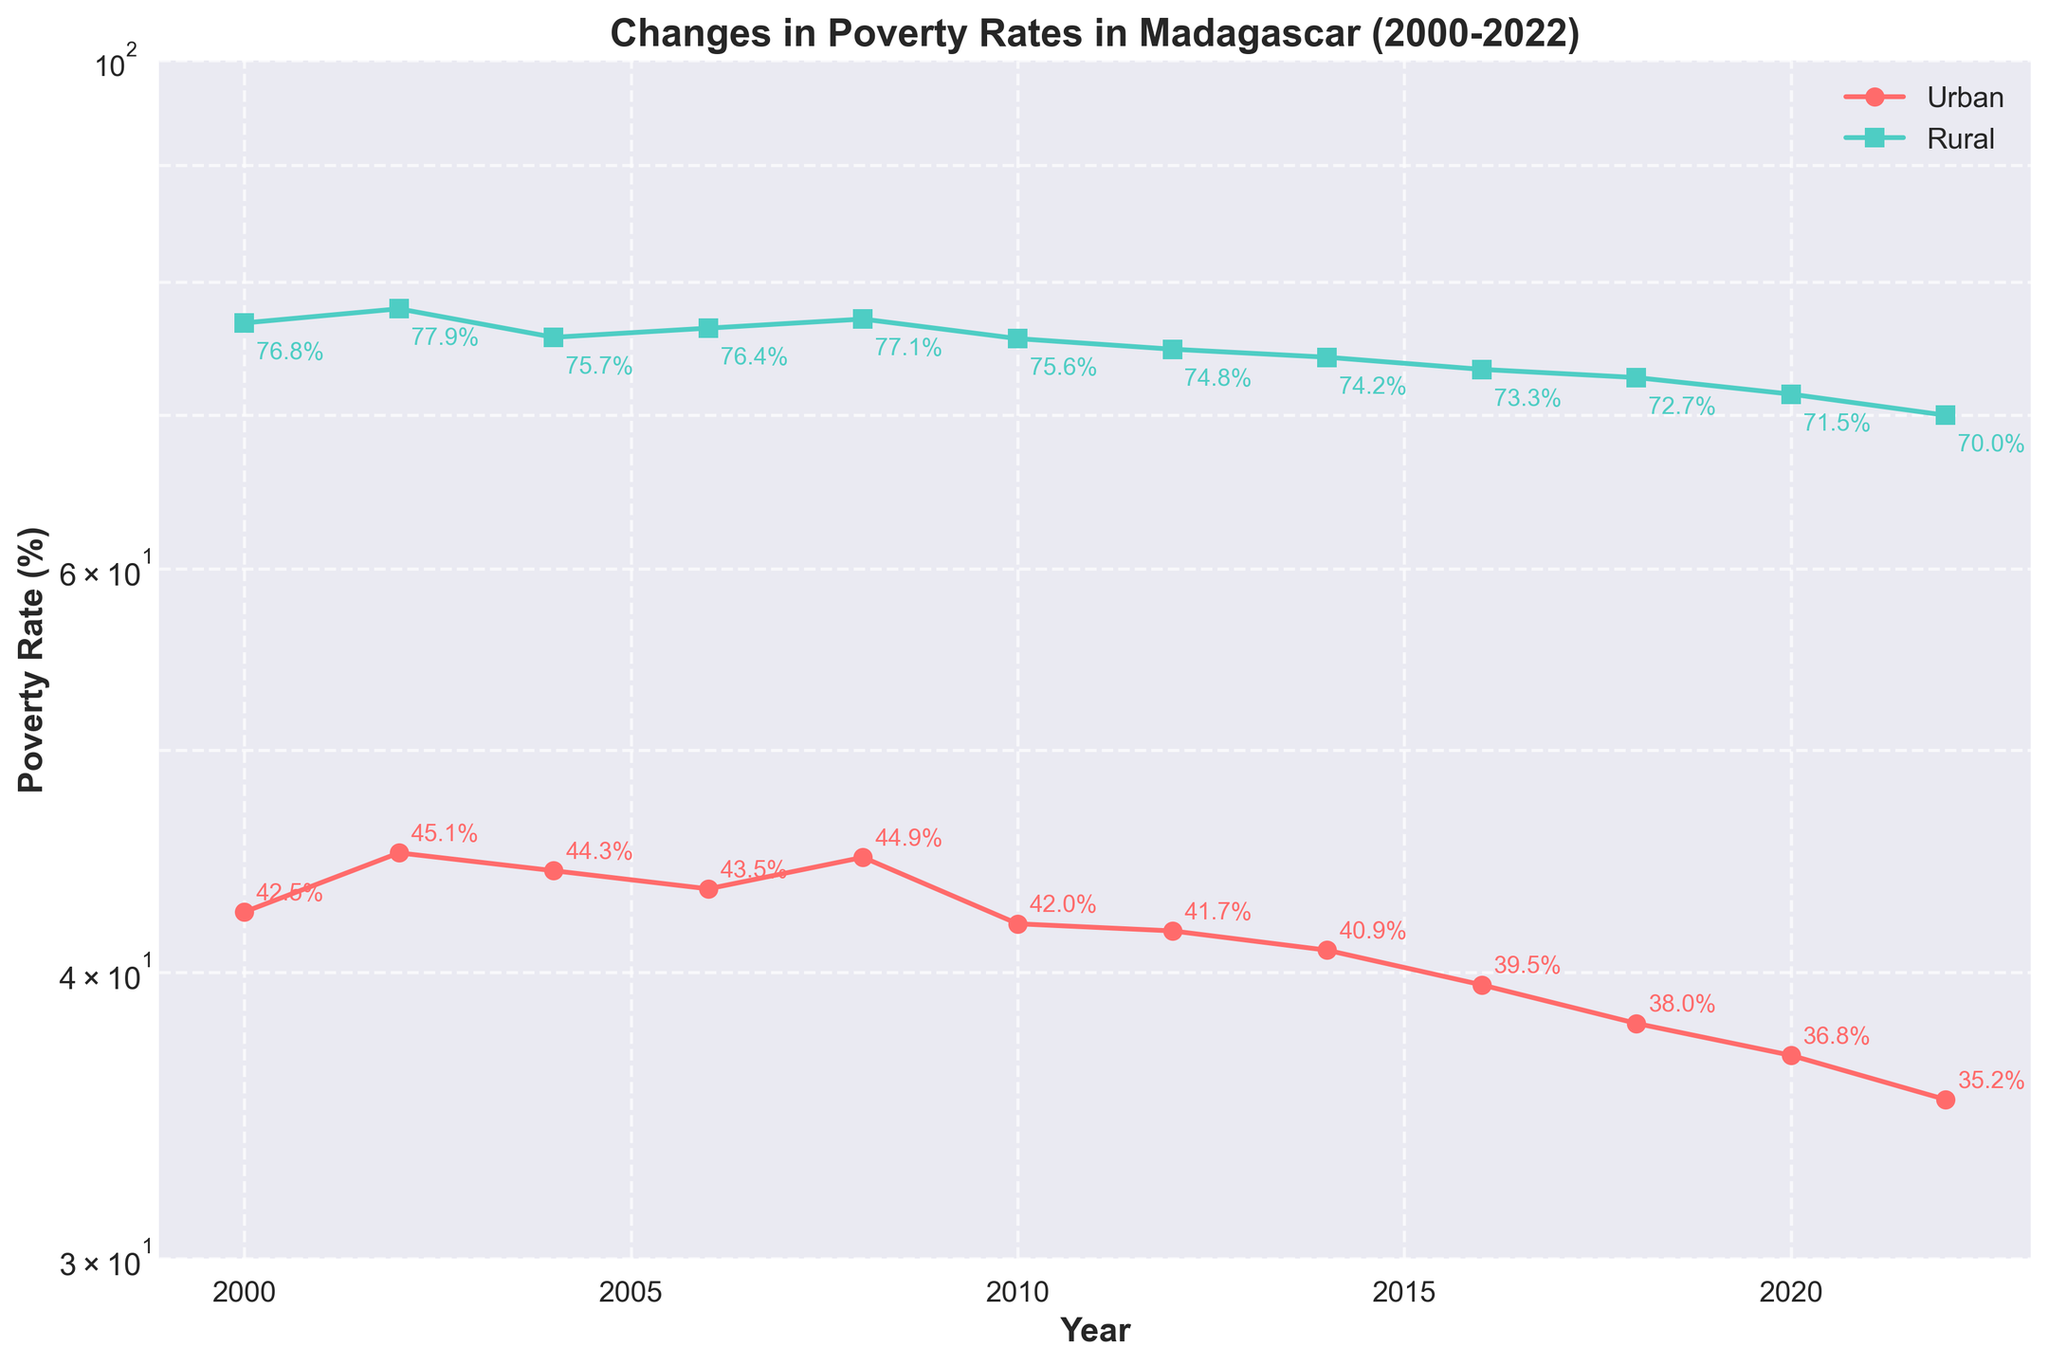What is the title of the plot? The title of the plot is displayed at the top of the figure in bold font, providing an overall summary of what the figure is representing.
Answer: Changes in Poverty Rates in Madagascar (2000-2022) What is the urban poverty rate in 2022? Find the value corresponding to the "Urban" line for the year 2022 and note the percentage.
Answer: 35.2% Which year had the highest rural poverty rate? Look across the "Rural" line and find the highest value, then refer back to the corresponding year.
Answer: 2002 How much did the urban poverty rate change between 2008 and 2018? Locate the values for the urban poverty rate in 2008 (44.9%) and 2018 (38.0%), then calculate the difference: 44.9% - 38.0%.
Answer: 6.9% Which area had a higher poverty rate in 2010, urban or rural? Compare the points for urban and rural in the year 2010 to see which is higher.
Answer: Rural What is the average rural poverty rate over the displayed period? Add the rural poverty rates for each recorded year and divide by the number of years (12). Calculation: (76.8 + 77.9 + 75.7 + 76.4 + 77.1 + 75.6 + 74.8 + 74.2 + 73.3 + 72.7 + 71.5 + 70.0) / 12.
Answer: 74.3% By how much did the rural poverty rate decrease from 2000 to 2022? Subtract the rural poverty rate in 2022 from the rate in 2000: 76.8% - 70.0%.
Answer: 6.8% Which year had the smallest difference between urban and rural poverty rates? Subtract the urban poverty rate from the rural poverty rate for each year, then identify the smallest difference.
Answer: 2022 What trend can be observed for both urban and rural poverty rates over the period? Examine the direction of the lines for both urban and rural rates from the start to the end year.
Answer: Decreasing How does the logarithmic scale affect the visual representation of changes in poverty rates? Notice that on a log scale, equal percentage changes appear as equal distances; this compresses larger values and expands smaller values to better illustrate relative changes.
Answer: It standardizes percentage changes across the range 